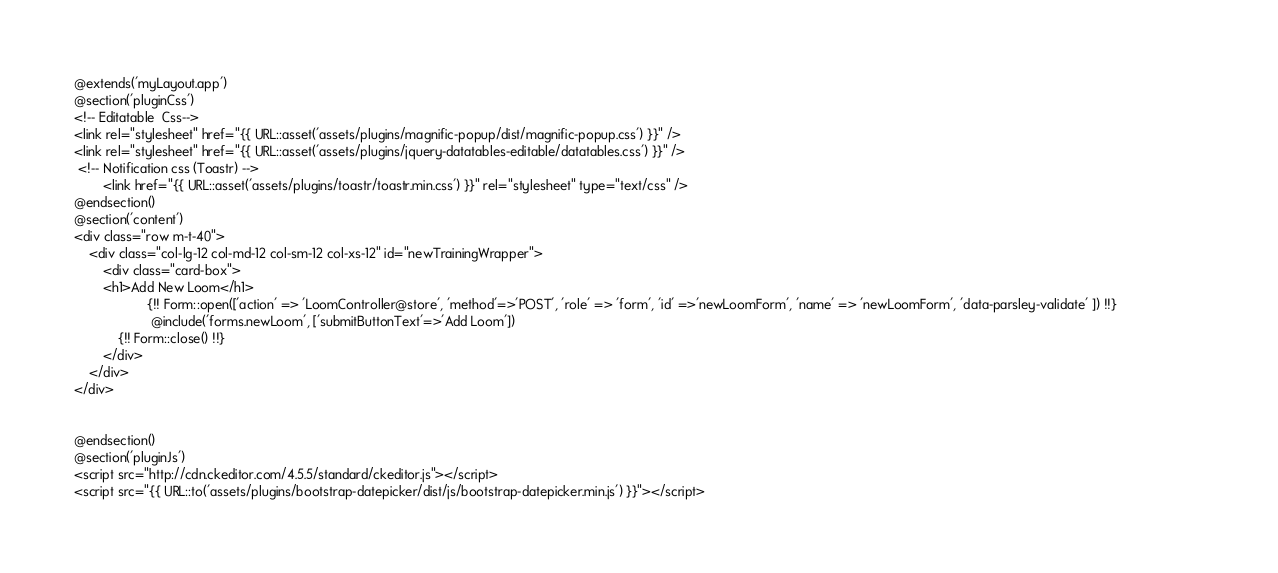Convert code to text. <code><loc_0><loc_0><loc_500><loc_500><_PHP_>@extends('myLayout.app')
@section('pluginCss')
<!-- Editatable  Css-->
<link rel="stylesheet" href="{{ URL::asset('assets/plugins/magnific-popup/dist/magnific-popup.css') }}" />
<link rel="stylesheet" href="{{ URL::asset('assets/plugins/jquery-datatables-editable/datatables.css') }}" />
 <!-- Notification css (Toastr) -->
        <link href="{{ URL::asset('assets/plugins/toastr/toastr.min.css') }}" rel="stylesheet" type="text/css" />
@endsection()
@section('content')
<div class="row m-t-40">
	<div class="col-lg-12 col-md-12 col-sm-12 col-xs-12" id="newTrainingWrapper">
		<div class="card-box">
		<h1>Add New Loom</h1>
					{!! Form::open(['action' => 'LoomController@store', 'method'=>'POST', 'role' => 'form', 'id' =>'newLoomForm', 'name' => 'newLoomForm', 'data-parsley-validate' ]) !!}                        
					 @include('forms.newLoom', ['submitButtonText'=>'Add Loom'])
			{!! Form::close() !!} 
		</div>
	</div>
</div>


@endsection()
@section('pluginJs')
<script src="http://cdn.ckeditor.com/4.5.5/standard/ckeditor.js"></script>
<script src="{{ URL::to('assets/plugins/bootstrap-datepicker/dist/js/bootstrap-datepicker.min.js') }}"></script></code> 